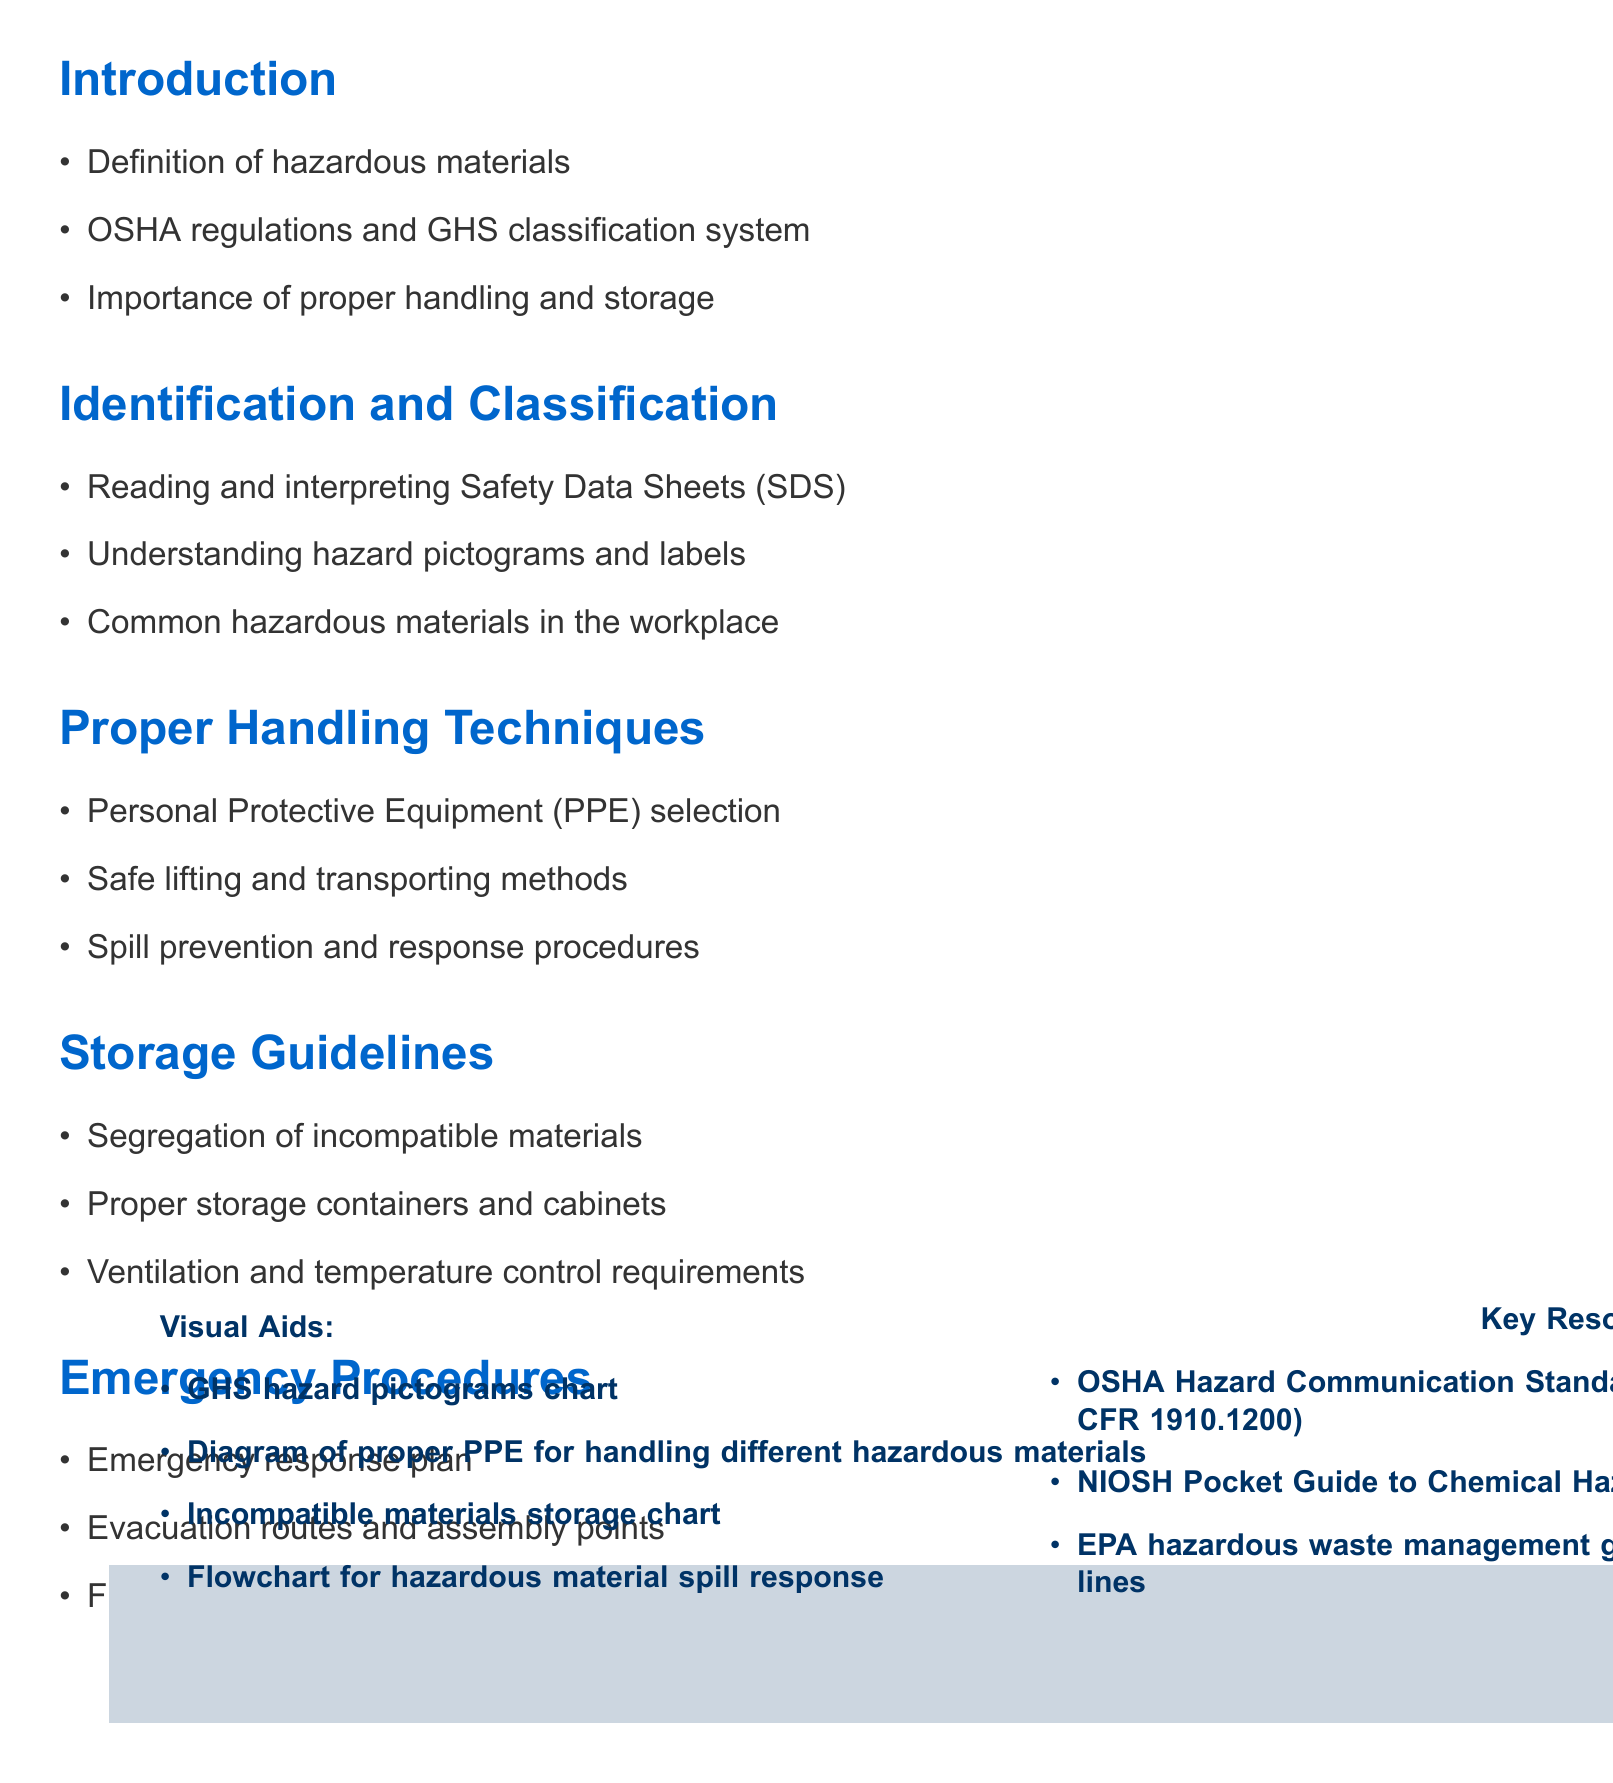What is the title of the training session? The title of the training session is presented at the top of the document.
Answer: Training Session: Proper Handling and Storage of Hazardous Materials How many sections are there in the document? The document is organized into multiple sections, which can be counted in the outline.
Answer: 5 What is one of the visual aids listed in the document? Visual aids are provided towards the end of the document and are enumerated in a list.
Answer: GHS hazard pictograms chart What is the first point under the "Identification and Classification" section? The points under each section are bullet points, and the first one can be clearly identified.
Answer: Reading and interpreting Safety Data Sheets (SDS) What guidelines are mentioned for storage? The "Storage Guidelines" section lists multiple points about storage practices that can be referenced.
Answer: Segregation of incompatible materials What document is referenced as a key resource? Key resources are highlighted at the bottom of the document and indicate essential references.
Answer: OSHA Hazard Communication Standard (29 CFR 1910.1200) What is one emergency procedure listed in the document? Emergency procedures are outlined in the relevant section of the document, identifying crucial action steps.
Answer: Emergency response plan What is the importance of proper handling and storage? The introduction emphasizes the significance of the topic covered in the session.
Answer: Importance of proper handling and storage What is the focus of the "Proper Handling Techniques" section? This section describes methods and practices for safely dealing with hazardous materials and can be derived from the title.
Answer: Personal Protective Equipment (PPE) selection 